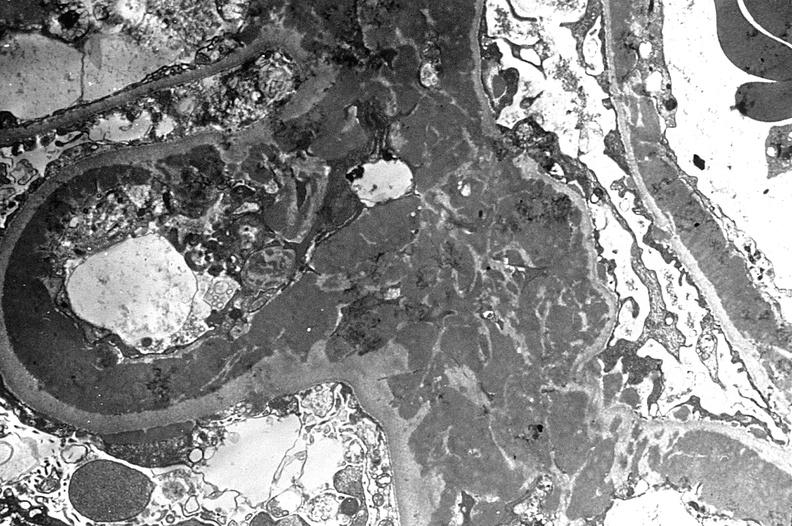s urinary present?
Answer the question using a single word or phrase. Yes 